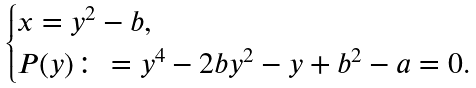<formula> <loc_0><loc_0><loc_500><loc_500>\begin{cases} x = y ^ { 2 } - b , \\ P ( y ) \colon = y ^ { 4 } - 2 b y ^ { 2 } - y + b ^ { 2 } - a = 0 . \end{cases}</formula> 